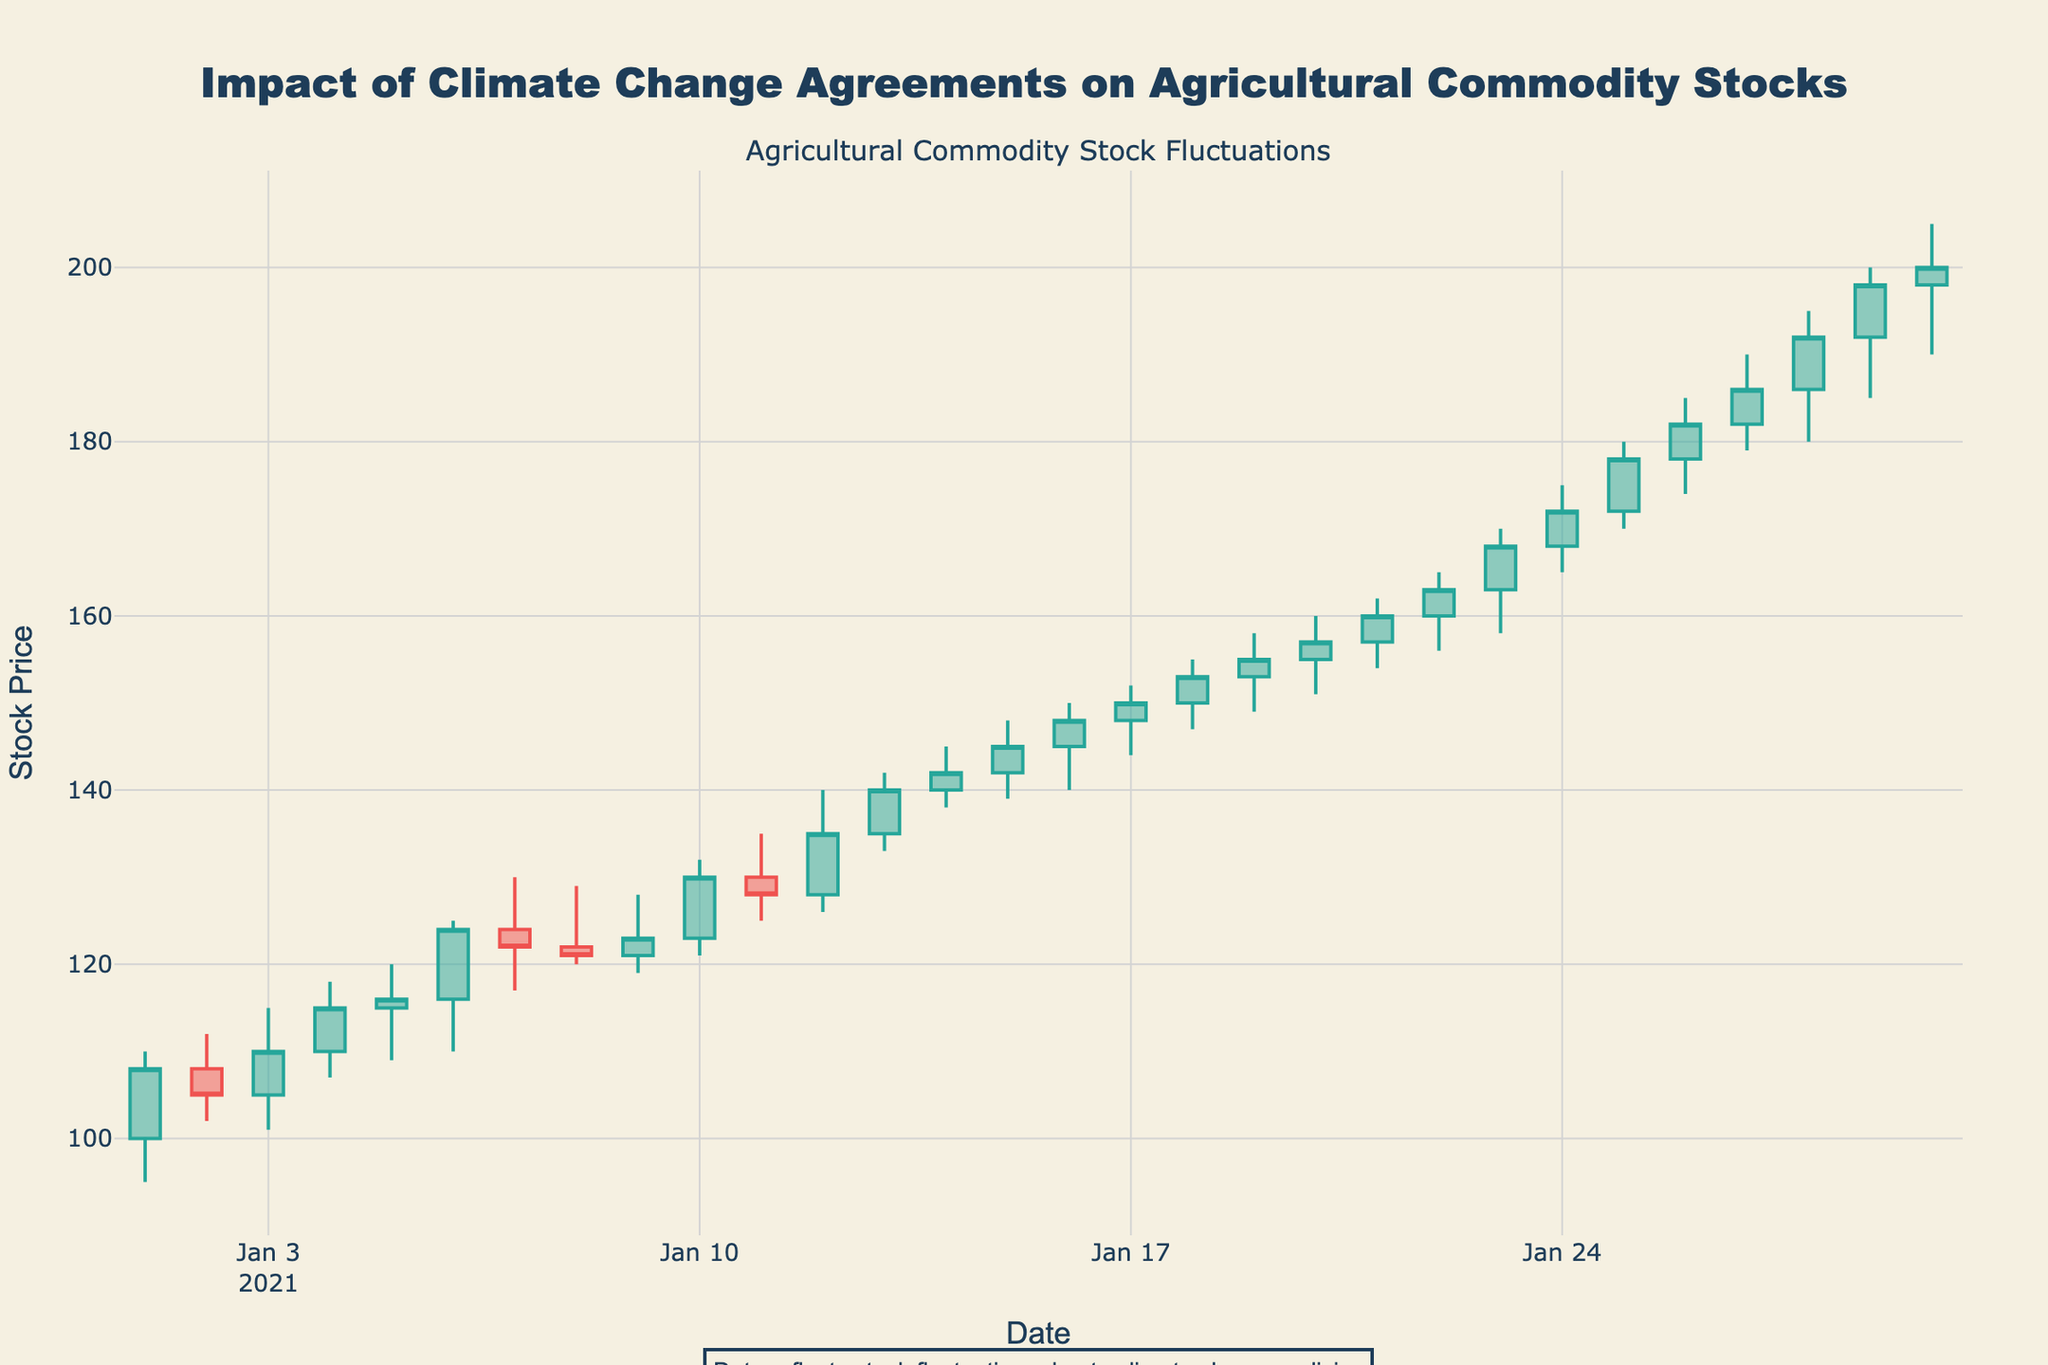What is the title of the chart? The title is positioned centered at the top of the chart and in a larger font. It reads "Impact of Climate Change Agreements on Agricultural Commodity Stocks."
Answer: Impact of Climate Change Agreements on Agricultural Commodity Stocks What does the color green generally indicate in this candlestick chart? The increasing line color is green, meaning if the stock closes higher than its opening price, the candlestick will be green. Hence, green indicates an increase in stock price.
Answer: An increase in stock price On which date did the stock price reach its highest close? By examining the closing values on the subsequent dates, we find that the stock price reached its highest close on the last date available in the data, which is January 30, 2021, at $200.
Answer: January 30, 2021 Which date had the highest high price and how much was that? By looking at the highest prices listed, January 29, 2021, had the highest high price which was $200.
Answer: January 29, 2021 - $200 Which dates exhibit a top shadow (high price was higher than the close price)? A top shadow occurs when the high price is higher than the close price. Examining the data, this pattern is present on several dates, including January 2, 2021, and January 7, 2021.
Answer: January 2, 2021, and January 7, 2021 How many days did the stock close higher than the opening price? Counting the number of days where the close price is greater than the open price shows that there were 17 such days.
Answer: 17 days What was the opening and closing price on January 25, 2021? The data shows that on January 25, 2021, the opening price was $172, and the closing price was $178.
Answer: $172 (Open), $178 (Close) Which date had the biggest single-day drop in closing price? By examining the close prices and noting the differences, January 11 to January 12 shows the biggest drop in closing price, from $130 to $128. The single-day drop is $2.
Answer: January 11 to January 12 What is the average closing price for the dates provided? Adding all the close prices and dividing by the number of data points: (108+105+110+...+200) / 30 = 141.3
Answer: 141.3 On which date does the candlestick have the largest lower shadow? Checking the data for each date, the largest difference between the low price and opening price, or low and close price (whichever is lower) occurs on January 28, 2021, where the low price was significantly lower than the open.
Answer: January 28, 2021 